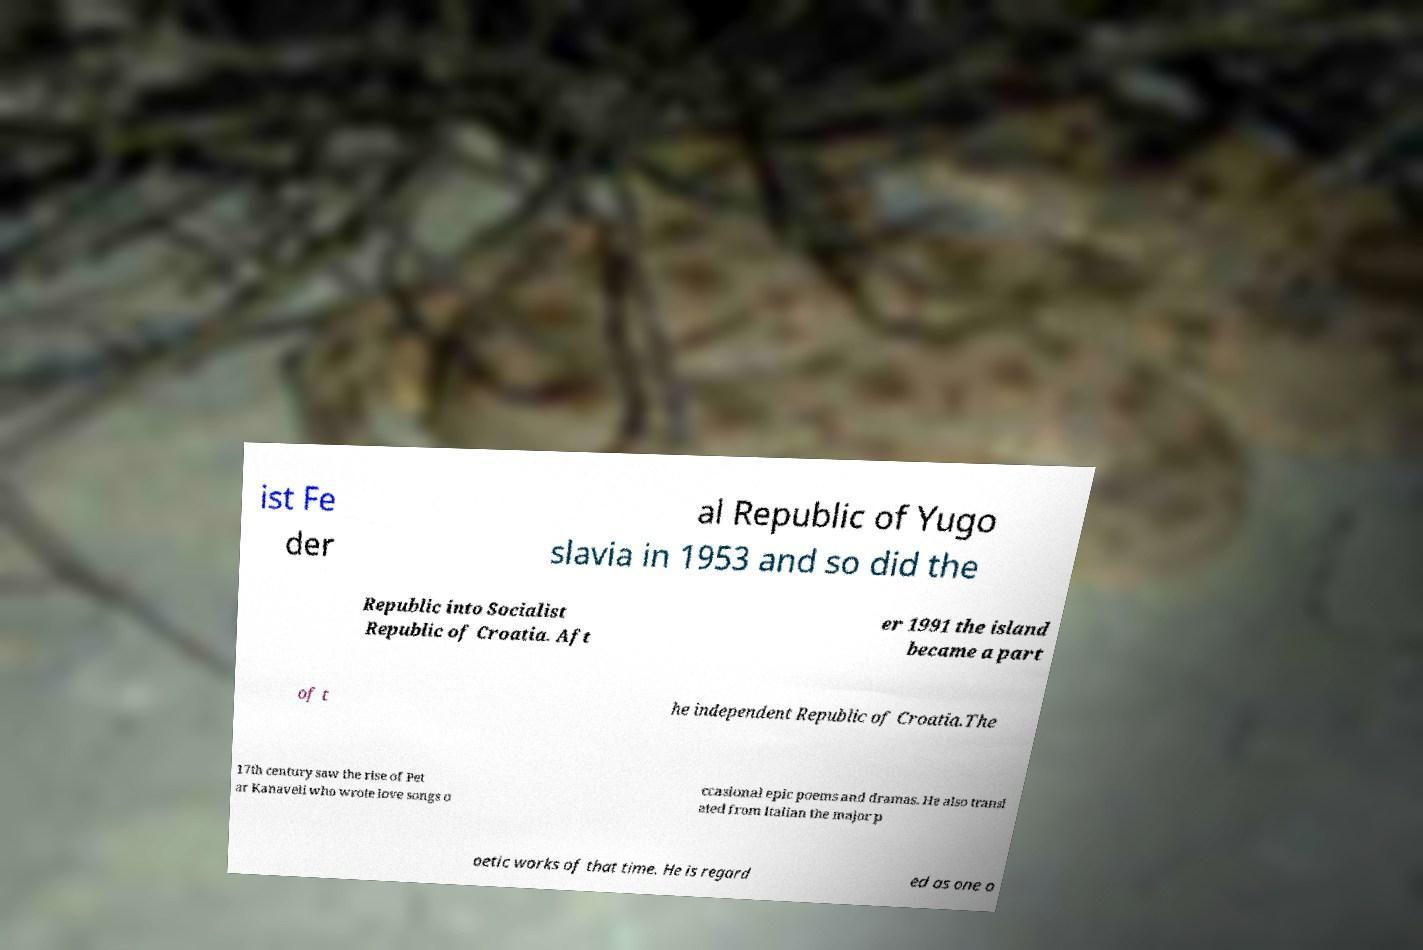Could you assist in decoding the text presented in this image and type it out clearly? ist Fe der al Republic of Yugo slavia in 1953 and so did the Republic into Socialist Republic of Croatia. Aft er 1991 the island became a part of t he independent Republic of Croatia.The 17th century saw the rise of Pet ar Kanaveli who wrote love songs o ccasional epic poems and dramas. He also transl ated from Italian the major p oetic works of that time. He is regard ed as one o 